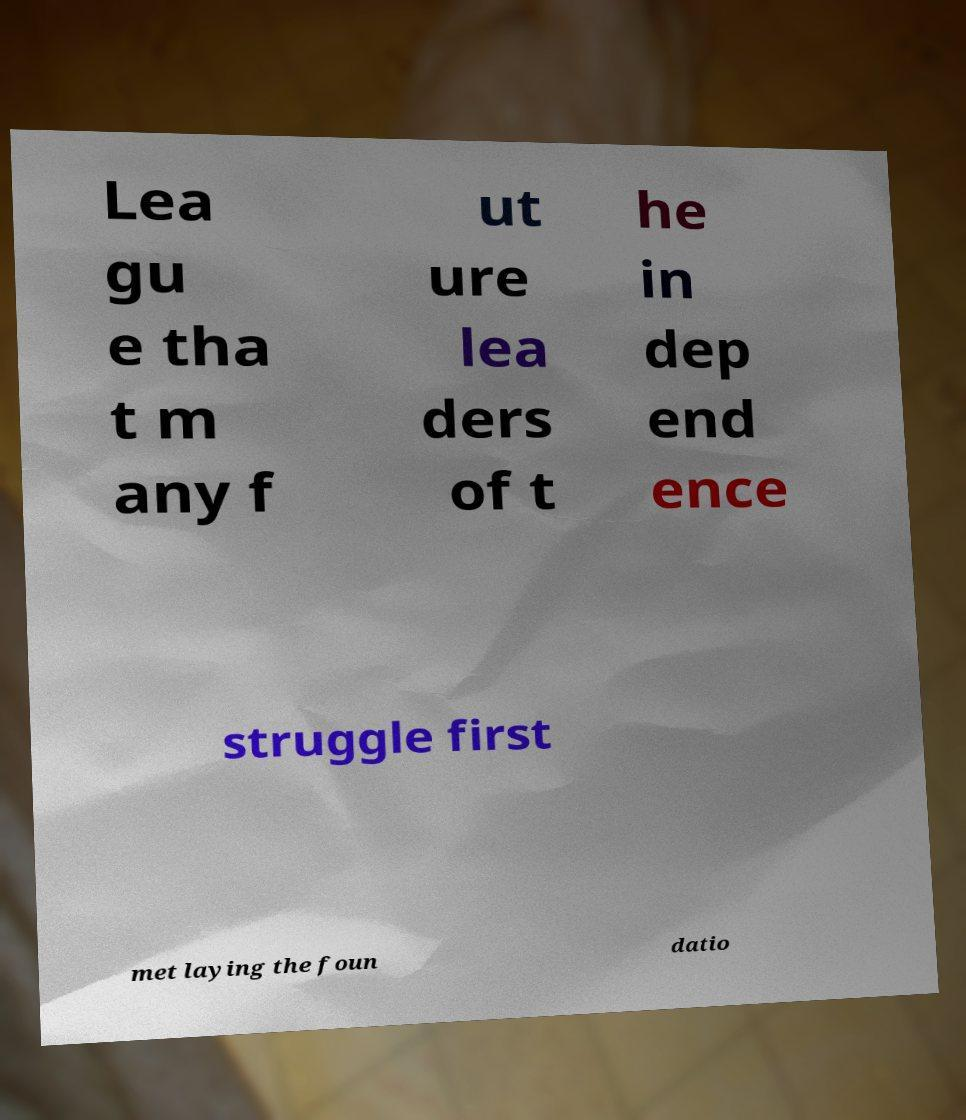I need the written content from this picture converted into text. Can you do that? Lea gu e tha t m any f ut ure lea ders of t he in dep end ence struggle first met laying the foun datio 